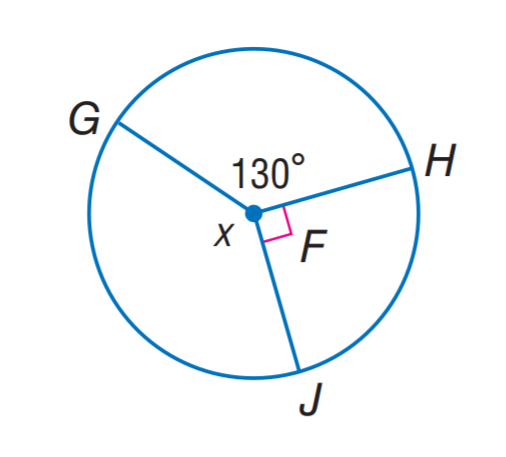Answer the mathemtical geometry problem and directly provide the correct option letter.
Question: Find x.
Choices: A: 90 B: 110 C: 130 D: 140 D 